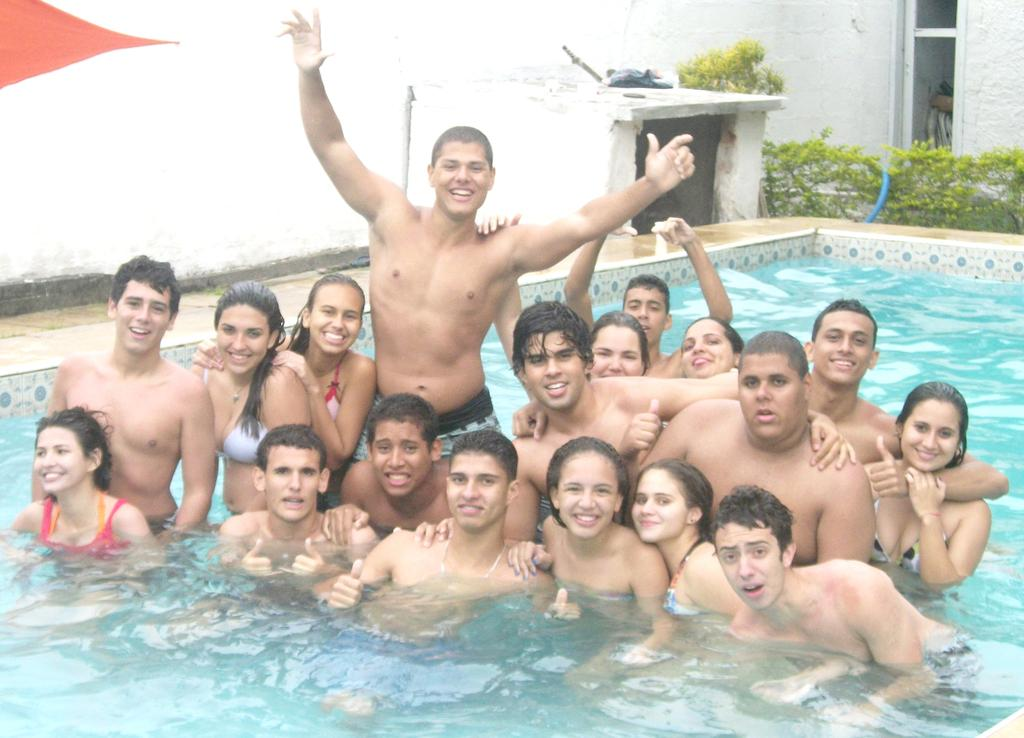Who or what is present in the image? There are persons in the image. What are the persons doing in the image? The persons are smiling. Where are the persons located in the image? The persons are in a swimming pool. What can be seen in the background of the image? There are plants, a blue color pipe, a pump house, and a white wall in the background of the image. What type of shade is provided by the giraffe in the image? There is no giraffe present in the image, so no shade can be provided by a giraffe. What sound does the bell make in the image? There is no bell present in the image, so no sound can be heard from a bell. 